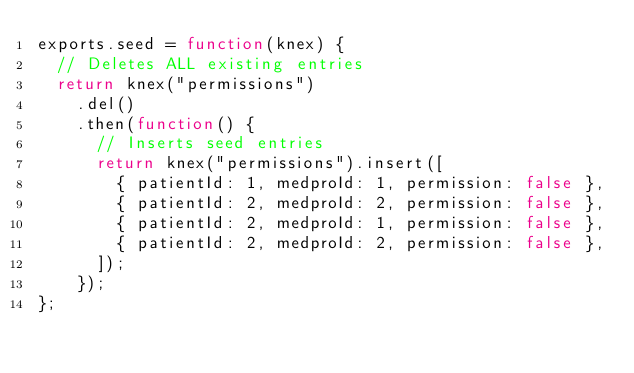Convert code to text. <code><loc_0><loc_0><loc_500><loc_500><_JavaScript_>exports.seed = function(knex) {
  // Deletes ALL existing entries
  return knex("permissions")
    .del()
    .then(function() {
      // Inserts seed entries
      return knex("permissions").insert([
        { patientId: 1, medproId: 1, permission: false },
        { patientId: 2, medproId: 2, permission: false },
        { patientId: 2, medproId: 1, permission: false },
        { patientId: 2, medproId: 2, permission: false },
      ]);
    });
};
</code> 